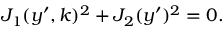Convert formula to latex. <formula><loc_0><loc_0><loc_500><loc_500>\begin{array} { r } { J _ { 1 } ( y ^ { \prime } , k ) ^ { 2 } + J _ { 2 } ( y ^ { \prime } ) ^ { 2 } = 0 . } \end{array}</formula> 